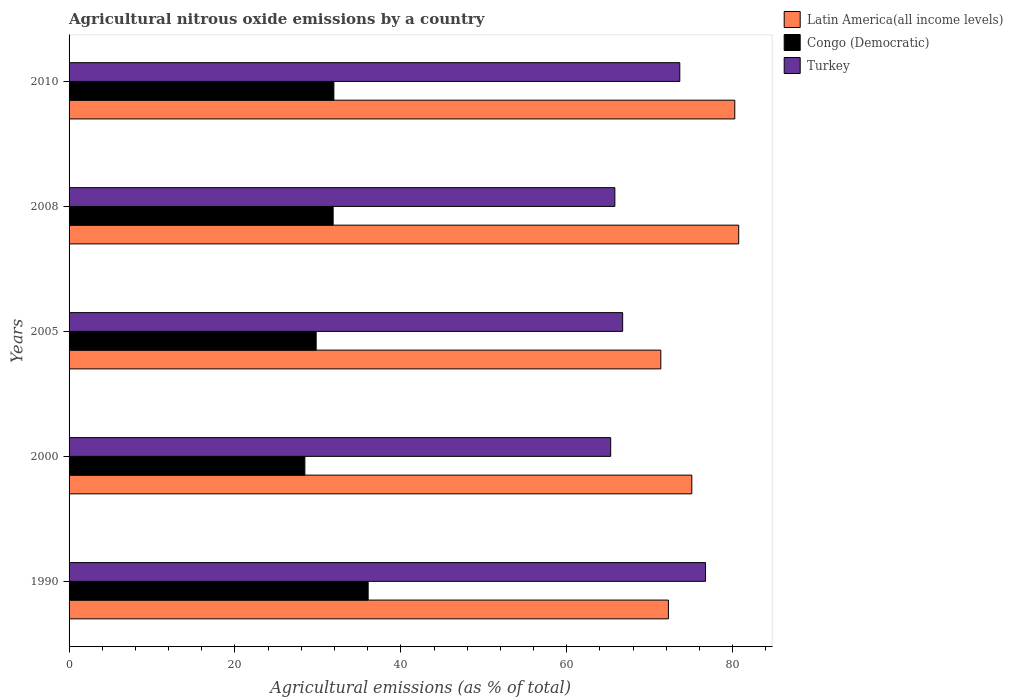How many different coloured bars are there?
Provide a succinct answer. 3. Are the number of bars on each tick of the Y-axis equal?
Your answer should be compact. Yes. What is the amount of agricultural nitrous oxide emitted in Congo (Democratic) in 2010?
Make the answer very short. 31.92. Across all years, what is the maximum amount of agricultural nitrous oxide emitted in Congo (Democratic)?
Keep it short and to the point. 36.06. Across all years, what is the minimum amount of agricultural nitrous oxide emitted in Congo (Democratic)?
Provide a short and direct response. 28.43. In which year was the amount of agricultural nitrous oxide emitted in Turkey maximum?
Provide a succinct answer. 1990. In which year was the amount of agricultural nitrous oxide emitted in Latin America(all income levels) minimum?
Provide a short and direct response. 2005. What is the total amount of agricultural nitrous oxide emitted in Turkey in the graph?
Make the answer very short. 348.2. What is the difference between the amount of agricultural nitrous oxide emitted in Latin America(all income levels) in 2000 and that in 2005?
Offer a terse response. 3.74. What is the difference between the amount of agricultural nitrous oxide emitted in Congo (Democratic) in 2010 and the amount of agricultural nitrous oxide emitted in Latin America(all income levels) in 2005?
Offer a very short reply. -39.42. What is the average amount of agricultural nitrous oxide emitted in Congo (Democratic) per year?
Your answer should be compact. 31.61. In the year 1990, what is the difference between the amount of agricultural nitrous oxide emitted in Latin America(all income levels) and amount of agricultural nitrous oxide emitted in Turkey?
Provide a succinct answer. -4.48. What is the ratio of the amount of agricultural nitrous oxide emitted in Congo (Democratic) in 1990 to that in 2008?
Give a very brief answer. 1.13. Is the difference between the amount of agricultural nitrous oxide emitted in Latin America(all income levels) in 2000 and 2010 greater than the difference between the amount of agricultural nitrous oxide emitted in Turkey in 2000 and 2010?
Provide a succinct answer. Yes. What is the difference between the highest and the second highest amount of agricultural nitrous oxide emitted in Congo (Democratic)?
Your answer should be compact. 4.13. What is the difference between the highest and the lowest amount of agricultural nitrous oxide emitted in Turkey?
Offer a terse response. 11.43. In how many years, is the amount of agricultural nitrous oxide emitted in Congo (Democratic) greater than the average amount of agricultural nitrous oxide emitted in Congo (Democratic) taken over all years?
Keep it short and to the point. 3. What does the 2nd bar from the top in 2008 represents?
Your answer should be compact. Congo (Democratic). What does the 1st bar from the bottom in 2005 represents?
Provide a short and direct response. Latin America(all income levels). Is it the case that in every year, the sum of the amount of agricultural nitrous oxide emitted in Turkey and amount of agricultural nitrous oxide emitted in Latin America(all income levels) is greater than the amount of agricultural nitrous oxide emitted in Congo (Democratic)?
Your answer should be compact. Yes. How many bars are there?
Keep it short and to the point. 15. Are all the bars in the graph horizontal?
Make the answer very short. Yes. How many years are there in the graph?
Your answer should be compact. 5. What is the difference between two consecutive major ticks on the X-axis?
Your answer should be compact. 20. Are the values on the major ticks of X-axis written in scientific E-notation?
Make the answer very short. No. Does the graph contain any zero values?
Give a very brief answer. No. How many legend labels are there?
Offer a very short reply. 3. How are the legend labels stacked?
Offer a terse response. Vertical. What is the title of the graph?
Keep it short and to the point. Agricultural nitrous oxide emissions by a country. Does "West Bank and Gaza" appear as one of the legend labels in the graph?
Ensure brevity in your answer.  No. What is the label or title of the X-axis?
Make the answer very short. Agricultural emissions (as % of total). What is the Agricultural emissions (as % of total) in Latin America(all income levels) in 1990?
Provide a succinct answer. 72.26. What is the Agricultural emissions (as % of total) in Congo (Democratic) in 1990?
Your response must be concise. 36.06. What is the Agricultural emissions (as % of total) of Turkey in 1990?
Offer a very short reply. 76.73. What is the Agricultural emissions (as % of total) in Latin America(all income levels) in 2000?
Ensure brevity in your answer.  75.08. What is the Agricultural emissions (as % of total) in Congo (Democratic) in 2000?
Offer a terse response. 28.43. What is the Agricultural emissions (as % of total) in Turkey in 2000?
Keep it short and to the point. 65.3. What is the Agricultural emissions (as % of total) of Latin America(all income levels) in 2005?
Provide a short and direct response. 71.34. What is the Agricultural emissions (as % of total) of Congo (Democratic) in 2005?
Make the answer very short. 29.79. What is the Agricultural emissions (as % of total) of Turkey in 2005?
Your answer should be compact. 66.74. What is the Agricultural emissions (as % of total) of Latin America(all income levels) in 2008?
Provide a succinct answer. 80.73. What is the Agricultural emissions (as % of total) in Congo (Democratic) in 2008?
Give a very brief answer. 31.84. What is the Agricultural emissions (as % of total) of Turkey in 2008?
Give a very brief answer. 65.8. What is the Agricultural emissions (as % of total) of Latin America(all income levels) in 2010?
Provide a short and direct response. 80.26. What is the Agricultural emissions (as % of total) of Congo (Democratic) in 2010?
Offer a terse response. 31.92. What is the Agricultural emissions (as % of total) in Turkey in 2010?
Give a very brief answer. 73.63. Across all years, what is the maximum Agricultural emissions (as % of total) of Latin America(all income levels)?
Make the answer very short. 80.73. Across all years, what is the maximum Agricultural emissions (as % of total) in Congo (Democratic)?
Your answer should be very brief. 36.06. Across all years, what is the maximum Agricultural emissions (as % of total) of Turkey?
Your response must be concise. 76.73. Across all years, what is the minimum Agricultural emissions (as % of total) of Latin America(all income levels)?
Give a very brief answer. 71.34. Across all years, what is the minimum Agricultural emissions (as % of total) of Congo (Democratic)?
Offer a very short reply. 28.43. Across all years, what is the minimum Agricultural emissions (as % of total) in Turkey?
Your answer should be very brief. 65.3. What is the total Agricultural emissions (as % of total) in Latin America(all income levels) in the graph?
Ensure brevity in your answer.  379.66. What is the total Agricultural emissions (as % of total) of Congo (Democratic) in the graph?
Ensure brevity in your answer.  158.03. What is the total Agricultural emissions (as % of total) of Turkey in the graph?
Provide a short and direct response. 348.2. What is the difference between the Agricultural emissions (as % of total) in Latin America(all income levels) in 1990 and that in 2000?
Ensure brevity in your answer.  -2.82. What is the difference between the Agricultural emissions (as % of total) in Congo (Democratic) in 1990 and that in 2000?
Provide a short and direct response. 7.63. What is the difference between the Agricultural emissions (as % of total) of Turkey in 1990 and that in 2000?
Give a very brief answer. 11.43. What is the difference between the Agricultural emissions (as % of total) of Latin America(all income levels) in 1990 and that in 2005?
Offer a terse response. 0.91. What is the difference between the Agricultural emissions (as % of total) in Congo (Democratic) in 1990 and that in 2005?
Make the answer very short. 6.27. What is the difference between the Agricultural emissions (as % of total) in Turkey in 1990 and that in 2005?
Your answer should be compact. 9.99. What is the difference between the Agricultural emissions (as % of total) in Latin America(all income levels) in 1990 and that in 2008?
Give a very brief answer. -8.47. What is the difference between the Agricultural emissions (as % of total) in Congo (Democratic) in 1990 and that in 2008?
Ensure brevity in your answer.  4.22. What is the difference between the Agricultural emissions (as % of total) in Turkey in 1990 and that in 2008?
Ensure brevity in your answer.  10.93. What is the difference between the Agricultural emissions (as % of total) of Latin America(all income levels) in 1990 and that in 2010?
Your answer should be compact. -8. What is the difference between the Agricultural emissions (as % of total) of Congo (Democratic) in 1990 and that in 2010?
Your answer should be compact. 4.13. What is the difference between the Agricultural emissions (as % of total) in Turkey in 1990 and that in 2010?
Offer a terse response. 3.1. What is the difference between the Agricultural emissions (as % of total) of Latin America(all income levels) in 2000 and that in 2005?
Your answer should be compact. 3.74. What is the difference between the Agricultural emissions (as % of total) of Congo (Democratic) in 2000 and that in 2005?
Your answer should be compact. -1.36. What is the difference between the Agricultural emissions (as % of total) of Turkey in 2000 and that in 2005?
Your response must be concise. -1.44. What is the difference between the Agricultural emissions (as % of total) in Latin America(all income levels) in 2000 and that in 2008?
Offer a terse response. -5.65. What is the difference between the Agricultural emissions (as % of total) in Congo (Democratic) in 2000 and that in 2008?
Offer a terse response. -3.41. What is the difference between the Agricultural emissions (as % of total) in Turkey in 2000 and that in 2008?
Offer a terse response. -0.5. What is the difference between the Agricultural emissions (as % of total) of Latin America(all income levels) in 2000 and that in 2010?
Provide a succinct answer. -5.18. What is the difference between the Agricultural emissions (as % of total) of Congo (Democratic) in 2000 and that in 2010?
Offer a very short reply. -3.5. What is the difference between the Agricultural emissions (as % of total) of Turkey in 2000 and that in 2010?
Your response must be concise. -8.33. What is the difference between the Agricultural emissions (as % of total) in Latin America(all income levels) in 2005 and that in 2008?
Provide a short and direct response. -9.39. What is the difference between the Agricultural emissions (as % of total) of Congo (Democratic) in 2005 and that in 2008?
Provide a succinct answer. -2.05. What is the difference between the Agricultural emissions (as % of total) in Turkey in 2005 and that in 2008?
Provide a succinct answer. 0.94. What is the difference between the Agricultural emissions (as % of total) in Latin America(all income levels) in 2005 and that in 2010?
Your answer should be very brief. -8.92. What is the difference between the Agricultural emissions (as % of total) in Congo (Democratic) in 2005 and that in 2010?
Your answer should be very brief. -2.13. What is the difference between the Agricultural emissions (as % of total) of Turkey in 2005 and that in 2010?
Your answer should be very brief. -6.89. What is the difference between the Agricultural emissions (as % of total) of Latin America(all income levels) in 2008 and that in 2010?
Keep it short and to the point. 0.47. What is the difference between the Agricultural emissions (as % of total) of Congo (Democratic) in 2008 and that in 2010?
Your answer should be compact. -0.09. What is the difference between the Agricultural emissions (as % of total) of Turkey in 2008 and that in 2010?
Provide a short and direct response. -7.83. What is the difference between the Agricultural emissions (as % of total) in Latin America(all income levels) in 1990 and the Agricultural emissions (as % of total) in Congo (Democratic) in 2000?
Ensure brevity in your answer.  43.83. What is the difference between the Agricultural emissions (as % of total) in Latin America(all income levels) in 1990 and the Agricultural emissions (as % of total) in Turkey in 2000?
Your answer should be very brief. 6.96. What is the difference between the Agricultural emissions (as % of total) of Congo (Democratic) in 1990 and the Agricultural emissions (as % of total) of Turkey in 2000?
Keep it short and to the point. -29.24. What is the difference between the Agricultural emissions (as % of total) of Latin America(all income levels) in 1990 and the Agricultural emissions (as % of total) of Congo (Democratic) in 2005?
Offer a terse response. 42.47. What is the difference between the Agricultural emissions (as % of total) in Latin America(all income levels) in 1990 and the Agricultural emissions (as % of total) in Turkey in 2005?
Provide a short and direct response. 5.52. What is the difference between the Agricultural emissions (as % of total) of Congo (Democratic) in 1990 and the Agricultural emissions (as % of total) of Turkey in 2005?
Give a very brief answer. -30.68. What is the difference between the Agricultural emissions (as % of total) of Latin America(all income levels) in 1990 and the Agricultural emissions (as % of total) of Congo (Democratic) in 2008?
Your answer should be very brief. 40.42. What is the difference between the Agricultural emissions (as % of total) in Latin America(all income levels) in 1990 and the Agricultural emissions (as % of total) in Turkey in 2008?
Your response must be concise. 6.46. What is the difference between the Agricultural emissions (as % of total) of Congo (Democratic) in 1990 and the Agricultural emissions (as % of total) of Turkey in 2008?
Ensure brevity in your answer.  -29.74. What is the difference between the Agricultural emissions (as % of total) of Latin America(all income levels) in 1990 and the Agricultural emissions (as % of total) of Congo (Democratic) in 2010?
Ensure brevity in your answer.  40.33. What is the difference between the Agricultural emissions (as % of total) of Latin America(all income levels) in 1990 and the Agricultural emissions (as % of total) of Turkey in 2010?
Offer a very short reply. -1.37. What is the difference between the Agricultural emissions (as % of total) of Congo (Democratic) in 1990 and the Agricultural emissions (as % of total) of Turkey in 2010?
Make the answer very short. -37.57. What is the difference between the Agricultural emissions (as % of total) in Latin America(all income levels) in 2000 and the Agricultural emissions (as % of total) in Congo (Democratic) in 2005?
Offer a terse response. 45.29. What is the difference between the Agricultural emissions (as % of total) in Latin America(all income levels) in 2000 and the Agricultural emissions (as % of total) in Turkey in 2005?
Ensure brevity in your answer.  8.34. What is the difference between the Agricultural emissions (as % of total) in Congo (Democratic) in 2000 and the Agricultural emissions (as % of total) in Turkey in 2005?
Provide a succinct answer. -38.31. What is the difference between the Agricultural emissions (as % of total) of Latin America(all income levels) in 2000 and the Agricultural emissions (as % of total) of Congo (Democratic) in 2008?
Make the answer very short. 43.24. What is the difference between the Agricultural emissions (as % of total) of Latin America(all income levels) in 2000 and the Agricultural emissions (as % of total) of Turkey in 2008?
Keep it short and to the point. 9.28. What is the difference between the Agricultural emissions (as % of total) of Congo (Democratic) in 2000 and the Agricultural emissions (as % of total) of Turkey in 2008?
Your response must be concise. -37.37. What is the difference between the Agricultural emissions (as % of total) of Latin America(all income levels) in 2000 and the Agricultural emissions (as % of total) of Congo (Democratic) in 2010?
Your answer should be compact. 43.15. What is the difference between the Agricultural emissions (as % of total) of Latin America(all income levels) in 2000 and the Agricultural emissions (as % of total) of Turkey in 2010?
Offer a terse response. 1.45. What is the difference between the Agricultural emissions (as % of total) of Congo (Democratic) in 2000 and the Agricultural emissions (as % of total) of Turkey in 2010?
Offer a very short reply. -45.2. What is the difference between the Agricultural emissions (as % of total) of Latin America(all income levels) in 2005 and the Agricultural emissions (as % of total) of Congo (Democratic) in 2008?
Offer a terse response. 39.51. What is the difference between the Agricultural emissions (as % of total) of Latin America(all income levels) in 2005 and the Agricultural emissions (as % of total) of Turkey in 2008?
Your response must be concise. 5.54. What is the difference between the Agricultural emissions (as % of total) of Congo (Democratic) in 2005 and the Agricultural emissions (as % of total) of Turkey in 2008?
Keep it short and to the point. -36.01. What is the difference between the Agricultural emissions (as % of total) in Latin America(all income levels) in 2005 and the Agricultural emissions (as % of total) in Congo (Democratic) in 2010?
Your answer should be compact. 39.42. What is the difference between the Agricultural emissions (as % of total) in Latin America(all income levels) in 2005 and the Agricultural emissions (as % of total) in Turkey in 2010?
Offer a terse response. -2.29. What is the difference between the Agricultural emissions (as % of total) of Congo (Democratic) in 2005 and the Agricultural emissions (as % of total) of Turkey in 2010?
Offer a very short reply. -43.84. What is the difference between the Agricultural emissions (as % of total) of Latin America(all income levels) in 2008 and the Agricultural emissions (as % of total) of Congo (Democratic) in 2010?
Provide a short and direct response. 48.81. What is the difference between the Agricultural emissions (as % of total) in Latin America(all income levels) in 2008 and the Agricultural emissions (as % of total) in Turkey in 2010?
Ensure brevity in your answer.  7.1. What is the difference between the Agricultural emissions (as % of total) of Congo (Democratic) in 2008 and the Agricultural emissions (as % of total) of Turkey in 2010?
Provide a short and direct response. -41.79. What is the average Agricultural emissions (as % of total) in Latin America(all income levels) per year?
Your answer should be very brief. 75.93. What is the average Agricultural emissions (as % of total) in Congo (Democratic) per year?
Offer a very short reply. 31.61. What is the average Agricultural emissions (as % of total) in Turkey per year?
Your response must be concise. 69.64. In the year 1990, what is the difference between the Agricultural emissions (as % of total) of Latin America(all income levels) and Agricultural emissions (as % of total) of Congo (Democratic)?
Your answer should be compact. 36.2. In the year 1990, what is the difference between the Agricultural emissions (as % of total) of Latin America(all income levels) and Agricultural emissions (as % of total) of Turkey?
Provide a short and direct response. -4.48. In the year 1990, what is the difference between the Agricultural emissions (as % of total) of Congo (Democratic) and Agricultural emissions (as % of total) of Turkey?
Your answer should be compact. -40.67. In the year 2000, what is the difference between the Agricultural emissions (as % of total) of Latin America(all income levels) and Agricultural emissions (as % of total) of Congo (Democratic)?
Your answer should be compact. 46.65. In the year 2000, what is the difference between the Agricultural emissions (as % of total) in Latin America(all income levels) and Agricultural emissions (as % of total) in Turkey?
Ensure brevity in your answer.  9.78. In the year 2000, what is the difference between the Agricultural emissions (as % of total) in Congo (Democratic) and Agricultural emissions (as % of total) in Turkey?
Your answer should be compact. -36.87. In the year 2005, what is the difference between the Agricultural emissions (as % of total) in Latin America(all income levels) and Agricultural emissions (as % of total) in Congo (Democratic)?
Your response must be concise. 41.55. In the year 2005, what is the difference between the Agricultural emissions (as % of total) in Latin America(all income levels) and Agricultural emissions (as % of total) in Turkey?
Offer a very short reply. 4.6. In the year 2005, what is the difference between the Agricultural emissions (as % of total) of Congo (Democratic) and Agricultural emissions (as % of total) of Turkey?
Offer a terse response. -36.95. In the year 2008, what is the difference between the Agricultural emissions (as % of total) of Latin America(all income levels) and Agricultural emissions (as % of total) of Congo (Democratic)?
Offer a very short reply. 48.89. In the year 2008, what is the difference between the Agricultural emissions (as % of total) of Latin America(all income levels) and Agricultural emissions (as % of total) of Turkey?
Keep it short and to the point. 14.93. In the year 2008, what is the difference between the Agricultural emissions (as % of total) of Congo (Democratic) and Agricultural emissions (as % of total) of Turkey?
Ensure brevity in your answer.  -33.96. In the year 2010, what is the difference between the Agricultural emissions (as % of total) of Latin America(all income levels) and Agricultural emissions (as % of total) of Congo (Democratic)?
Your response must be concise. 48.33. In the year 2010, what is the difference between the Agricultural emissions (as % of total) in Latin America(all income levels) and Agricultural emissions (as % of total) in Turkey?
Provide a succinct answer. 6.63. In the year 2010, what is the difference between the Agricultural emissions (as % of total) of Congo (Democratic) and Agricultural emissions (as % of total) of Turkey?
Make the answer very short. -41.71. What is the ratio of the Agricultural emissions (as % of total) in Latin America(all income levels) in 1990 to that in 2000?
Make the answer very short. 0.96. What is the ratio of the Agricultural emissions (as % of total) in Congo (Democratic) in 1990 to that in 2000?
Your answer should be very brief. 1.27. What is the ratio of the Agricultural emissions (as % of total) in Turkey in 1990 to that in 2000?
Your answer should be compact. 1.18. What is the ratio of the Agricultural emissions (as % of total) in Latin America(all income levels) in 1990 to that in 2005?
Your answer should be very brief. 1.01. What is the ratio of the Agricultural emissions (as % of total) in Congo (Democratic) in 1990 to that in 2005?
Keep it short and to the point. 1.21. What is the ratio of the Agricultural emissions (as % of total) of Turkey in 1990 to that in 2005?
Provide a short and direct response. 1.15. What is the ratio of the Agricultural emissions (as % of total) of Latin America(all income levels) in 1990 to that in 2008?
Offer a terse response. 0.9. What is the ratio of the Agricultural emissions (as % of total) in Congo (Democratic) in 1990 to that in 2008?
Provide a short and direct response. 1.13. What is the ratio of the Agricultural emissions (as % of total) in Turkey in 1990 to that in 2008?
Offer a terse response. 1.17. What is the ratio of the Agricultural emissions (as % of total) of Latin America(all income levels) in 1990 to that in 2010?
Your response must be concise. 0.9. What is the ratio of the Agricultural emissions (as % of total) in Congo (Democratic) in 1990 to that in 2010?
Your response must be concise. 1.13. What is the ratio of the Agricultural emissions (as % of total) in Turkey in 1990 to that in 2010?
Offer a very short reply. 1.04. What is the ratio of the Agricultural emissions (as % of total) in Latin America(all income levels) in 2000 to that in 2005?
Your response must be concise. 1.05. What is the ratio of the Agricultural emissions (as % of total) in Congo (Democratic) in 2000 to that in 2005?
Offer a terse response. 0.95. What is the ratio of the Agricultural emissions (as % of total) in Turkey in 2000 to that in 2005?
Your answer should be compact. 0.98. What is the ratio of the Agricultural emissions (as % of total) in Congo (Democratic) in 2000 to that in 2008?
Make the answer very short. 0.89. What is the ratio of the Agricultural emissions (as % of total) of Latin America(all income levels) in 2000 to that in 2010?
Offer a terse response. 0.94. What is the ratio of the Agricultural emissions (as % of total) of Congo (Democratic) in 2000 to that in 2010?
Your answer should be compact. 0.89. What is the ratio of the Agricultural emissions (as % of total) of Turkey in 2000 to that in 2010?
Give a very brief answer. 0.89. What is the ratio of the Agricultural emissions (as % of total) of Latin America(all income levels) in 2005 to that in 2008?
Make the answer very short. 0.88. What is the ratio of the Agricultural emissions (as % of total) of Congo (Democratic) in 2005 to that in 2008?
Your answer should be compact. 0.94. What is the ratio of the Agricultural emissions (as % of total) of Turkey in 2005 to that in 2008?
Offer a terse response. 1.01. What is the ratio of the Agricultural emissions (as % of total) of Latin America(all income levels) in 2005 to that in 2010?
Your answer should be very brief. 0.89. What is the ratio of the Agricultural emissions (as % of total) in Congo (Democratic) in 2005 to that in 2010?
Your response must be concise. 0.93. What is the ratio of the Agricultural emissions (as % of total) of Turkey in 2005 to that in 2010?
Your answer should be very brief. 0.91. What is the ratio of the Agricultural emissions (as % of total) in Latin America(all income levels) in 2008 to that in 2010?
Ensure brevity in your answer.  1.01. What is the ratio of the Agricultural emissions (as % of total) in Turkey in 2008 to that in 2010?
Offer a terse response. 0.89. What is the difference between the highest and the second highest Agricultural emissions (as % of total) of Latin America(all income levels)?
Give a very brief answer. 0.47. What is the difference between the highest and the second highest Agricultural emissions (as % of total) of Congo (Democratic)?
Your response must be concise. 4.13. What is the difference between the highest and the second highest Agricultural emissions (as % of total) of Turkey?
Provide a short and direct response. 3.1. What is the difference between the highest and the lowest Agricultural emissions (as % of total) of Latin America(all income levels)?
Your answer should be very brief. 9.39. What is the difference between the highest and the lowest Agricultural emissions (as % of total) of Congo (Democratic)?
Your response must be concise. 7.63. What is the difference between the highest and the lowest Agricultural emissions (as % of total) of Turkey?
Make the answer very short. 11.43. 